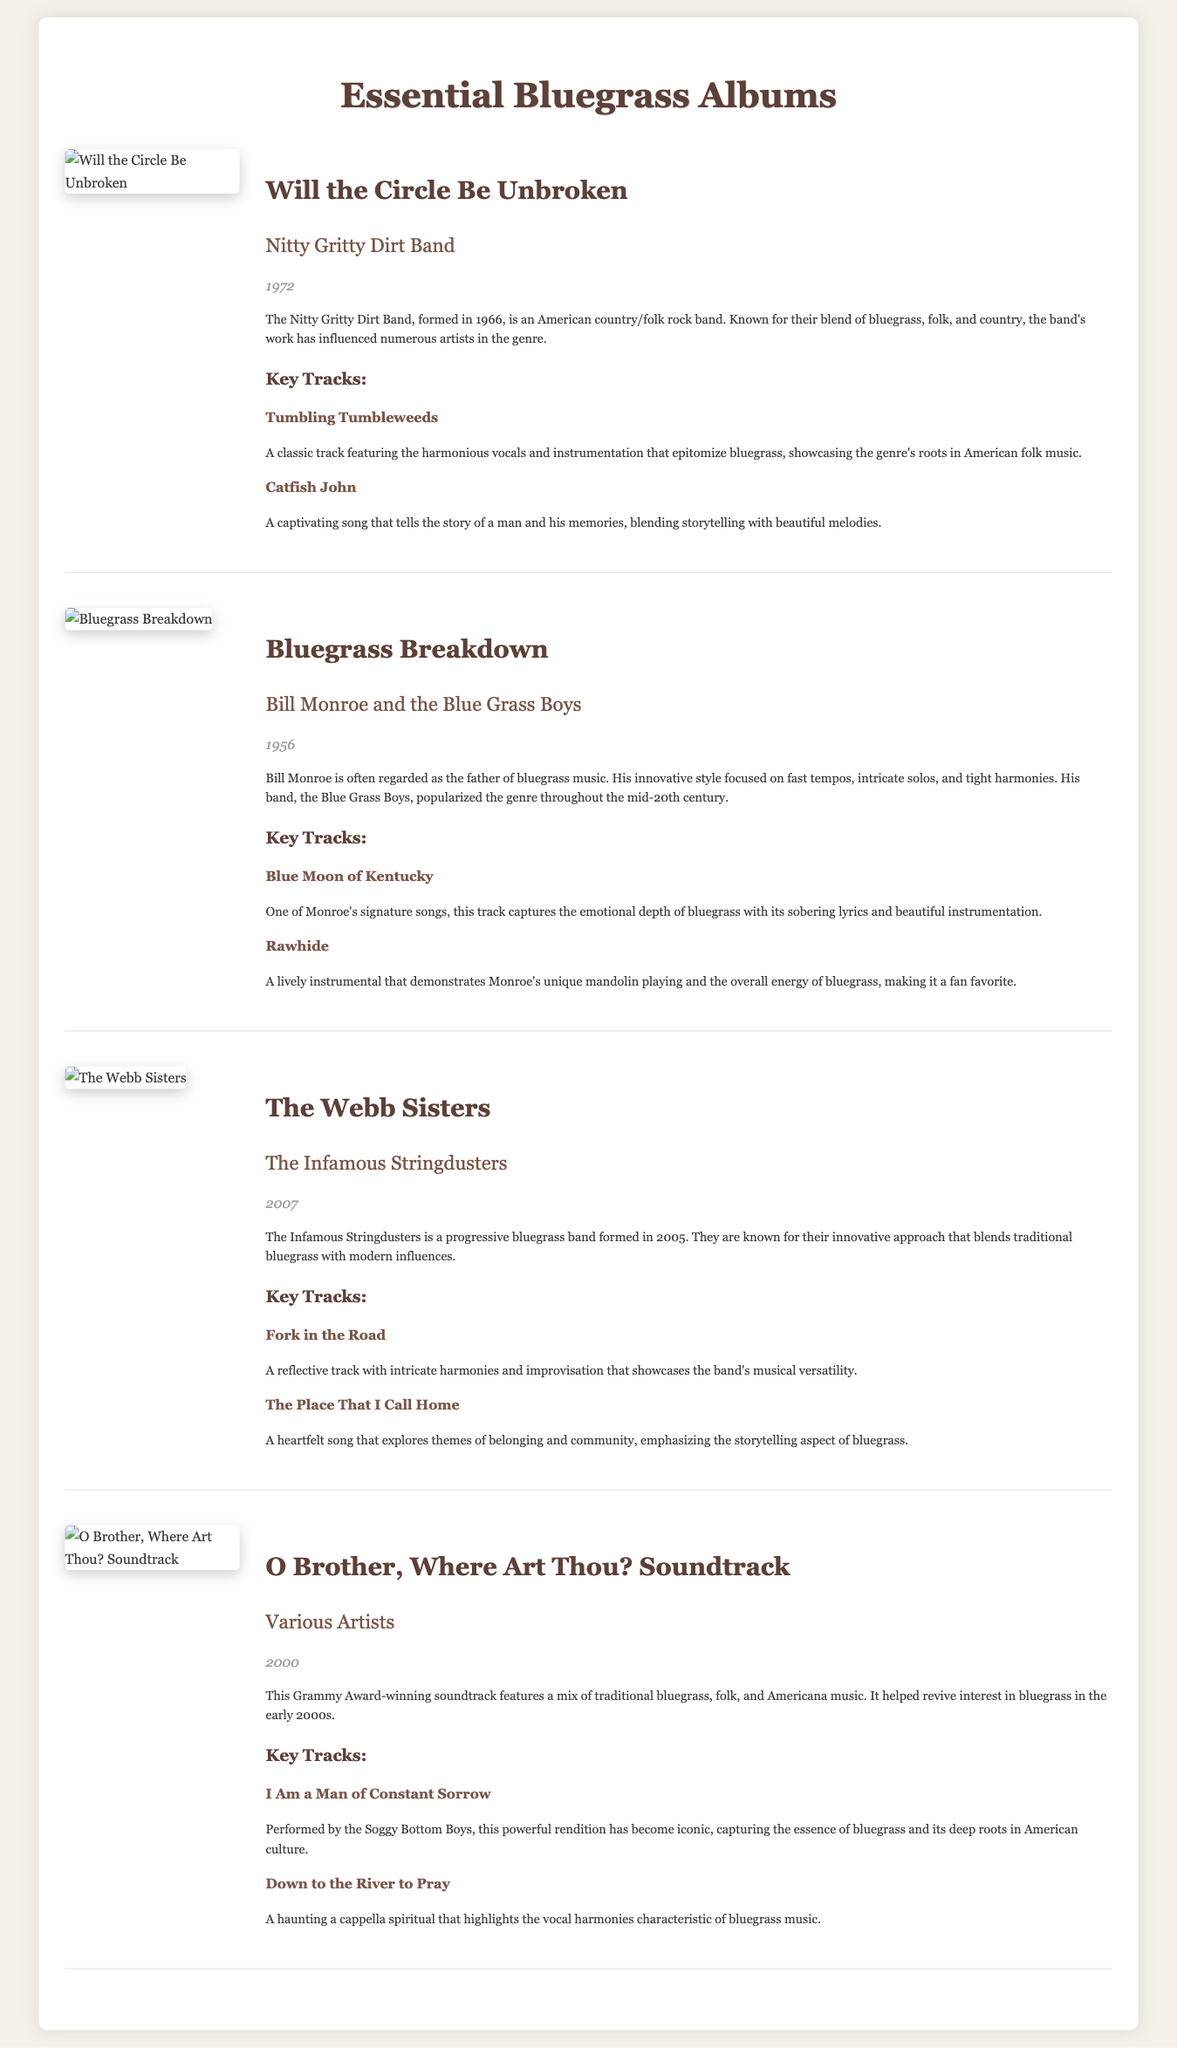What year was "Will the Circle Be Unbroken" released? The year of release for this album is stated in the document.
Answer: 1972 Who is the artist behind "Bluegrass Breakdown"? The document specifies the artist for this album.
Answer: Bill Monroe and the Blue Grass Boys How many key tracks are listed for "The Webb Sisters"? The number of key tracks can be counted in the document for this album.
Answer: 2 What genre of music is associated with the compilation "O Brother, Where Art Thou? Soundtrack"? The document describes the genre featured in this soundtrack.
Answer: Bluegrass Which song on the "Bluegrass Breakdown" album features sobering lyrics? The document indicates a key track with emotional depth.
Answer: Blue Moon of Kentucky What is the primary theme of "The Place That I Call Home"? The document discusses the themes explored in this key track.
Answer: Belonging and community In which year was "O Brother, Where Art Thou? Soundtrack" released? The year of release for this compilation is mentioned in the document.
Answer: 2000 Who performed "I Am a Man of Constant Sorrow"? The artist performing this track is detailed in the document.
Answer: The Soggy Bottom Boys How is the Nitty Gritty Dirt Band described? The document provides a brief bio of this artist.
Answer: American country/folk rock band 